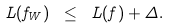<formula> <loc_0><loc_0><loc_500><loc_500>\L L ( f _ { W } ) \ \leq \ \L L ( f ) + \Delta .</formula> 